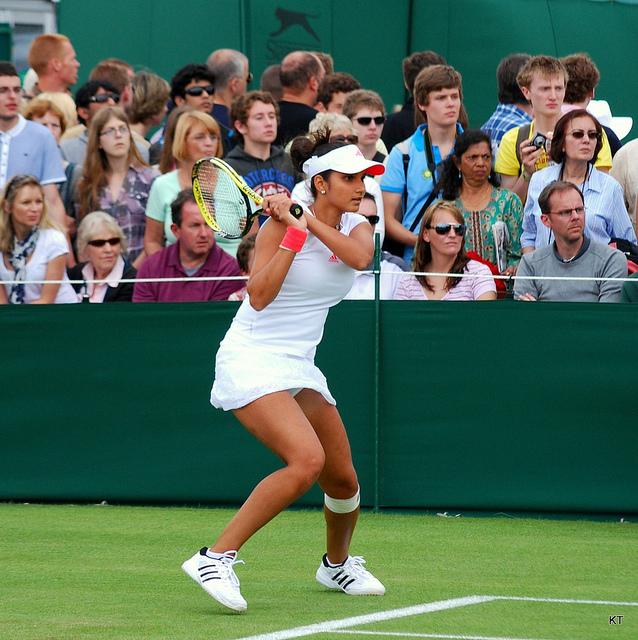How many people are wearing sunglasses?
Quick response, please. 6. What lady in the crowd is pulling a crazy face?
Give a very brief answer. None. Is this woman a talented athlete?
Give a very brief answer. Yes. 